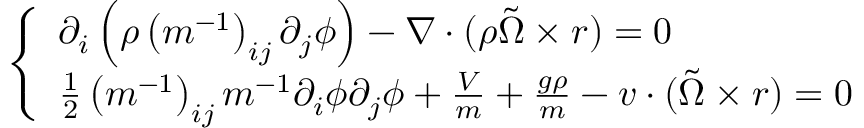Convert formula to latex. <formula><loc_0><loc_0><loc_500><loc_500>\left \{ \begin{array} { l } { \partial _ { i } \left ( \rho \left ( m ^ { - 1 } \right ) _ { i j } \partial _ { j } \phi \right ) - \nabla \cdot ( \rho \tilde { \Omega } \times r ) = 0 } \\ { \frac { 1 } { 2 } \left ( m ^ { - 1 } \right ) _ { i j } m ^ { - 1 } \partial _ { i } \phi \partial _ { j } \phi + \frac { V } { m } + \frac { g \rho } { m } - v \cdot ( \tilde { \Omega } \times r ) = 0 } \end{array}</formula> 